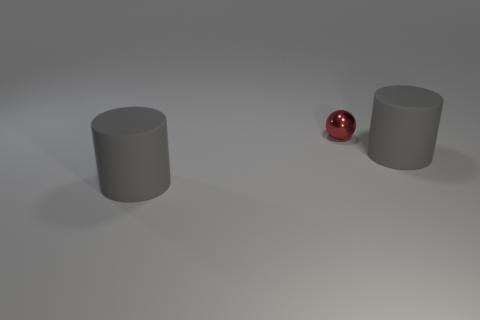There is a cylinder left of the metallic ball; is its size the same as the red object?
Make the answer very short. No. Are there the same number of gray rubber things that are in front of the red thing and green matte cylinders?
Your response must be concise. No. What is the color of the tiny shiny ball?
Your response must be concise. Red. Is there a yellow rubber thing that has the same size as the red shiny sphere?
Your response must be concise. No. Are there any large rubber things that have the same shape as the shiny thing?
Offer a terse response. No. The large thing behind the gray cylinder left of the metal ball is what shape?
Make the answer very short. Cylinder. There is a small red metallic thing; what shape is it?
Provide a short and direct response. Sphere. What is the material of the large gray thing that is to the right of the big gray rubber cylinder in front of the matte cylinder that is on the right side of the tiny red ball?
Offer a very short reply. Rubber. What number of other objects are there of the same material as the red object?
Your response must be concise. 0. What number of gray cylinders are to the left of the gray rubber thing to the right of the tiny metallic object?
Your answer should be very brief. 1. 